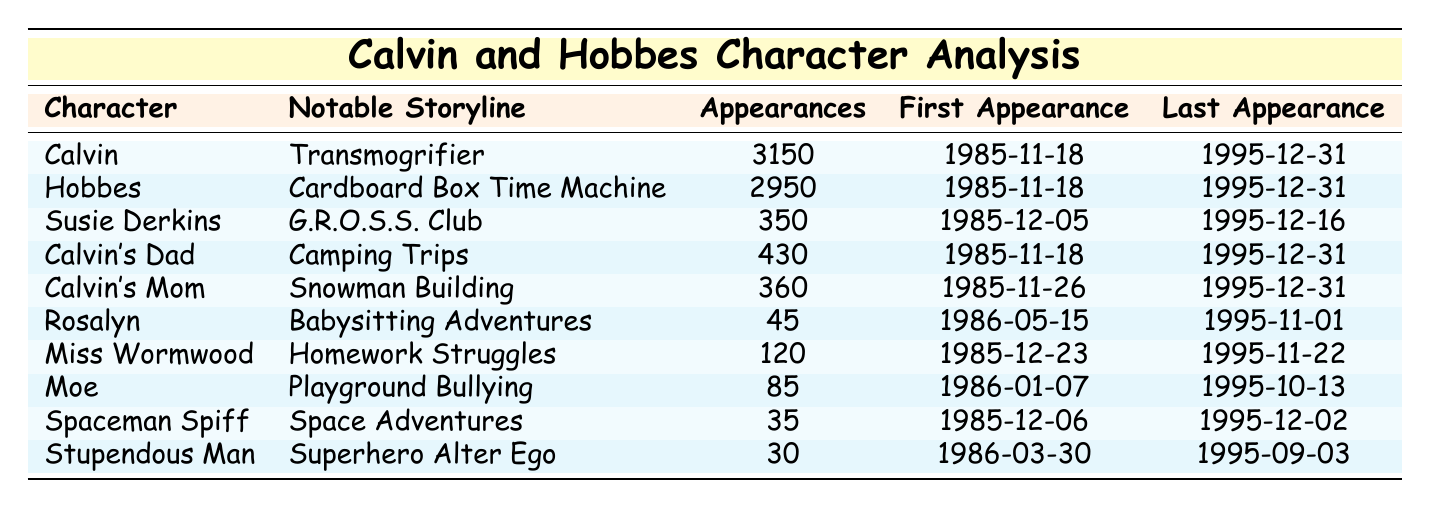What is the character with the most appearances? Looking at the "Appearances" column, Calvin has the highest count with 3150 appearances.
Answer: Calvin Who made their first appearance on 1985-11-18? Calvin, Hobbes, and Calvin's Dad all made their first appearance on 1985-11-18.
Answer: Calvin, Hobbes, Calvin's Dad What is the notable storyline of Susie Derkins? The table shows that Susie Derkins is associated with the G.R.O.S.S. Club storyline.
Answer: G.R.O.S.S. Club Which character has the least appearances? In the "Appearances" column, Stupendous Man has the least count with only 30 appearances.
Answer: Stupendous Man How many characters appeared more than 400 times? By counting the "Appearances" values, four characters (Calvin, Hobbes, Calvin's Dad, and Calvin's Mom) have more than 400 appearances.
Answer: 4 What is the difference in appearance counts between Calvin and Hobbes? The difference is calculated as 3150 (Calvin) - 2950 (Hobbes) = 200.
Answer: 200 Which character appeared last and what was the date? The last appearance date listed is for Calvin's Mom, on 1995-12-31.
Answer: Calvin's Mom, 1995-12-31 Is Rosalyn's first appearance earlier than Calvin's Mom's? Since Rosalyn's first appearance is on 1986-05-15 and Calvin's Mom's is on 1985-11-26, Rosalyn's first appearance is later.
Answer: No Which character had a storyline related to space adventures? According to the "Notable Storyline" column, Spaceman Spiff had a storyline related to space adventures.
Answer: Spaceman Spiff Calculate the average appearances of all listed characters. Total appearances: 3150 + 2950 + 350 + 430 + 360 + 45 + 120 + 85 + 35 + 30 =  4975. There are 10 characters, so the average is 4975 / 10 = 497.5.
Answer: 497.5 What character has a storyline involving homework? The table indicates that Miss Wormwood is associated with the Homework Struggles storyline.
Answer: Miss Wormwood If a character first appeared on 1985-12-06, what is their name? Checking the "First Appearance" date, the character who first appeared on that date is Spaceman Spiff.
Answer: Spaceman Spiff 